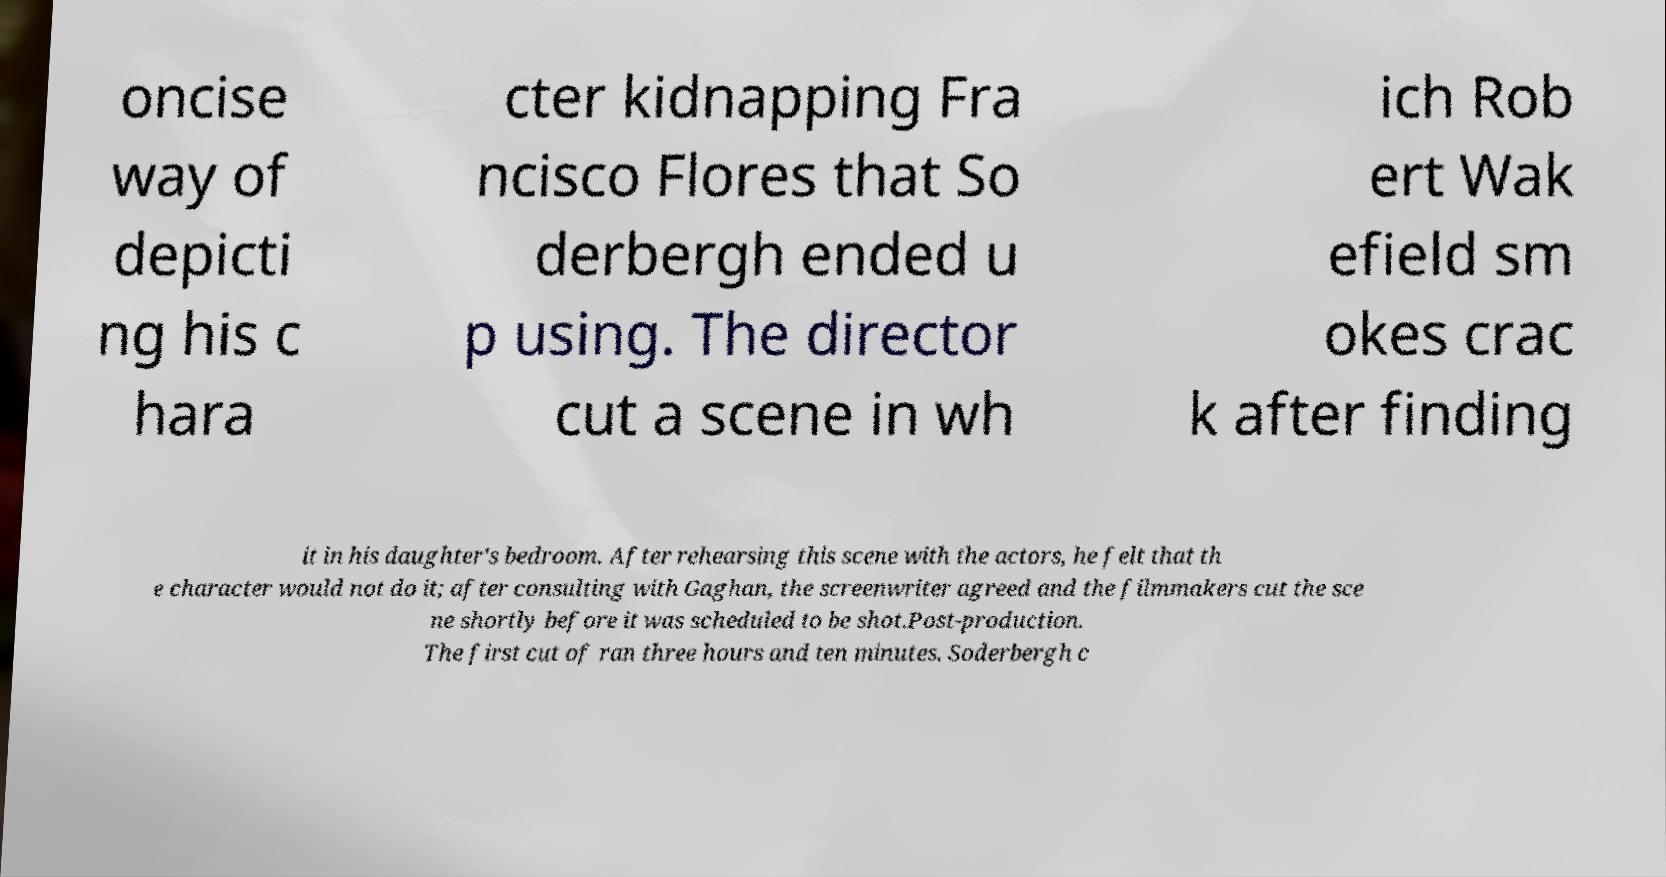There's text embedded in this image that I need extracted. Can you transcribe it verbatim? oncise way of depicti ng his c hara cter kidnapping Fra ncisco Flores that So derbergh ended u p using. The director cut a scene in wh ich Rob ert Wak efield sm okes crac k after finding it in his daughter's bedroom. After rehearsing this scene with the actors, he felt that th e character would not do it; after consulting with Gaghan, the screenwriter agreed and the filmmakers cut the sce ne shortly before it was scheduled to be shot.Post-production. The first cut of ran three hours and ten minutes. Soderbergh c 